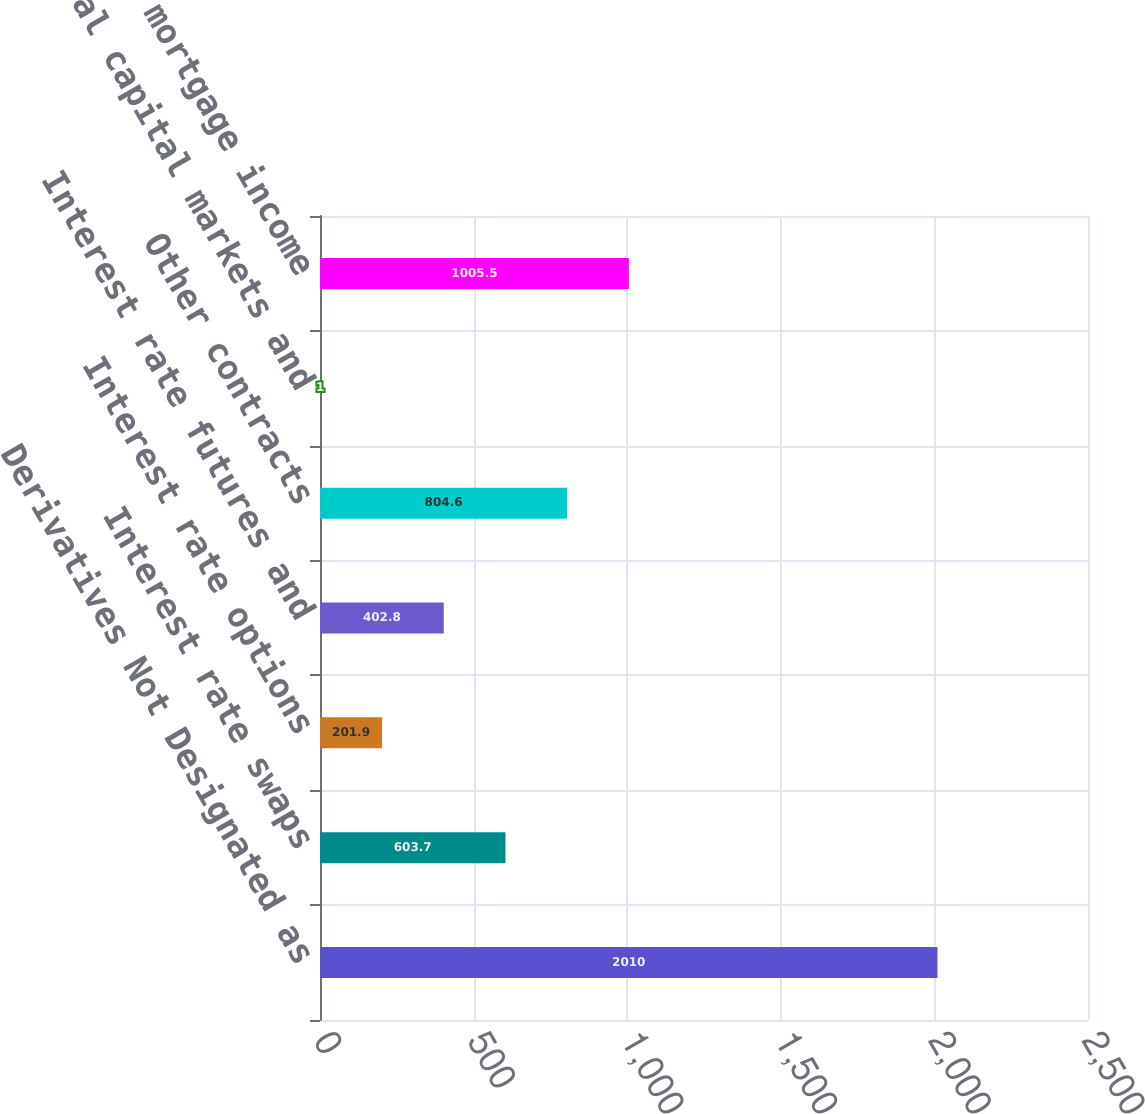<chart> <loc_0><loc_0><loc_500><loc_500><bar_chart><fcel>Derivatives Not Designated as<fcel>Interest rate swaps<fcel>Interest rate options<fcel>Interest rate futures and<fcel>Other contracts<fcel>Total capital markets and<fcel>Total mortgage income<nl><fcel>2010<fcel>603.7<fcel>201.9<fcel>402.8<fcel>804.6<fcel>1<fcel>1005.5<nl></chart> 